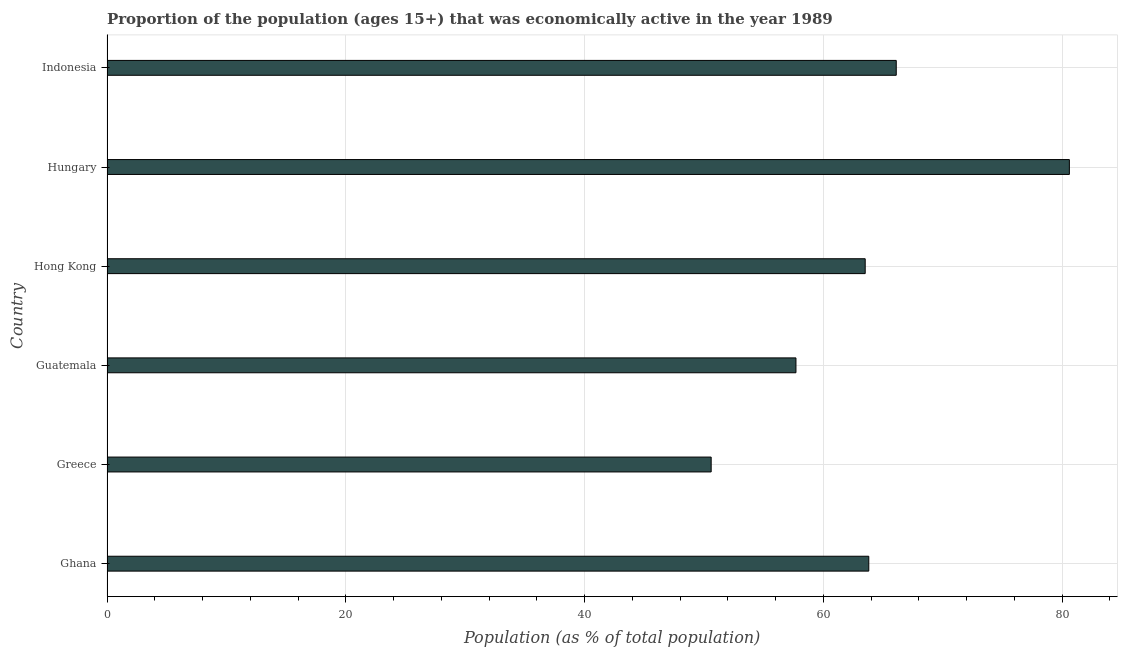Does the graph contain any zero values?
Make the answer very short. No. Does the graph contain grids?
Offer a very short reply. Yes. What is the title of the graph?
Your answer should be compact. Proportion of the population (ages 15+) that was economically active in the year 1989. What is the label or title of the X-axis?
Give a very brief answer. Population (as % of total population). What is the label or title of the Y-axis?
Provide a succinct answer. Country. What is the percentage of economically active population in Ghana?
Your response must be concise. 63.8. Across all countries, what is the maximum percentage of economically active population?
Provide a succinct answer. 80.6. Across all countries, what is the minimum percentage of economically active population?
Provide a short and direct response. 50.6. In which country was the percentage of economically active population maximum?
Provide a succinct answer. Hungary. In which country was the percentage of economically active population minimum?
Offer a very short reply. Greece. What is the sum of the percentage of economically active population?
Your answer should be very brief. 382.3. What is the average percentage of economically active population per country?
Offer a terse response. 63.72. What is the median percentage of economically active population?
Your answer should be compact. 63.65. What is the ratio of the percentage of economically active population in Guatemala to that in Hong Kong?
Keep it short and to the point. 0.91. Is the percentage of economically active population in Guatemala less than that in Hong Kong?
Ensure brevity in your answer.  Yes. Is the difference between the percentage of economically active population in Hong Kong and Hungary greater than the difference between any two countries?
Provide a succinct answer. No. Is the sum of the percentage of economically active population in Ghana and Indonesia greater than the maximum percentage of economically active population across all countries?
Your answer should be very brief. Yes. What is the difference between the highest and the lowest percentage of economically active population?
Keep it short and to the point. 30. How many bars are there?
Provide a short and direct response. 6. Are all the bars in the graph horizontal?
Provide a succinct answer. Yes. What is the difference between two consecutive major ticks on the X-axis?
Give a very brief answer. 20. What is the Population (as % of total population) of Ghana?
Your answer should be very brief. 63.8. What is the Population (as % of total population) of Greece?
Your answer should be compact. 50.6. What is the Population (as % of total population) in Guatemala?
Your answer should be very brief. 57.7. What is the Population (as % of total population) in Hong Kong?
Your response must be concise. 63.5. What is the Population (as % of total population) of Hungary?
Make the answer very short. 80.6. What is the Population (as % of total population) in Indonesia?
Offer a terse response. 66.1. What is the difference between the Population (as % of total population) in Ghana and Greece?
Offer a terse response. 13.2. What is the difference between the Population (as % of total population) in Ghana and Hong Kong?
Ensure brevity in your answer.  0.3. What is the difference between the Population (as % of total population) in Ghana and Hungary?
Your answer should be very brief. -16.8. What is the difference between the Population (as % of total population) in Greece and Guatemala?
Keep it short and to the point. -7.1. What is the difference between the Population (as % of total population) in Greece and Indonesia?
Provide a short and direct response. -15.5. What is the difference between the Population (as % of total population) in Guatemala and Hungary?
Your answer should be very brief. -22.9. What is the difference between the Population (as % of total population) in Guatemala and Indonesia?
Offer a very short reply. -8.4. What is the difference between the Population (as % of total population) in Hong Kong and Hungary?
Give a very brief answer. -17.1. What is the difference between the Population (as % of total population) in Hungary and Indonesia?
Provide a short and direct response. 14.5. What is the ratio of the Population (as % of total population) in Ghana to that in Greece?
Make the answer very short. 1.26. What is the ratio of the Population (as % of total population) in Ghana to that in Guatemala?
Your answer should be very brief. 1.11. What is the ratio of the Population (as % of total population) in Ghana to that in Hungary?
Your answer should be compact. 0.79. What is the ratio of the Population (as % of total population) in Greece to that in Guatemala?
Give a very brief answer. 0.88. What is the ratio of the Population (as % of total population) in Greece to that in Hong Kong?
Make the answer very short. 0.8. What is the ratio of the Population (as % of total population) in Greece to that in Hungary?
Offer a terse response. 0.63. What is the ratio of the Population (as % of total population) in Greece to that in Indonesia?
Your response must be concise. 0.77. What is the ratio of the Population (as % of total population) in Guatemala to that in Hong Kong?
Your response must be concise. 0.91. What is the ratio of the Population (as % of total population) in Guatemala to that in Hungary?
Offer a terse response. 0.72. What is the ratio of the Population (as % of total population) in Guatemala to that in Indonesia?
Provide a succinct answer. 0.87. What is the ratio of the Population (as % of total population) in Hong Kong to that in Hungary?
Provide a succinct answer. 0.79. What is the ratio of the Population (as % of total population) in Hong Kong to that in Indonesia?
Your response must be concise. 0.96. What is the ratio of the Population (as % of total population) in Hungary to that in Indonesia?
Your response must be concise. 1.22. 